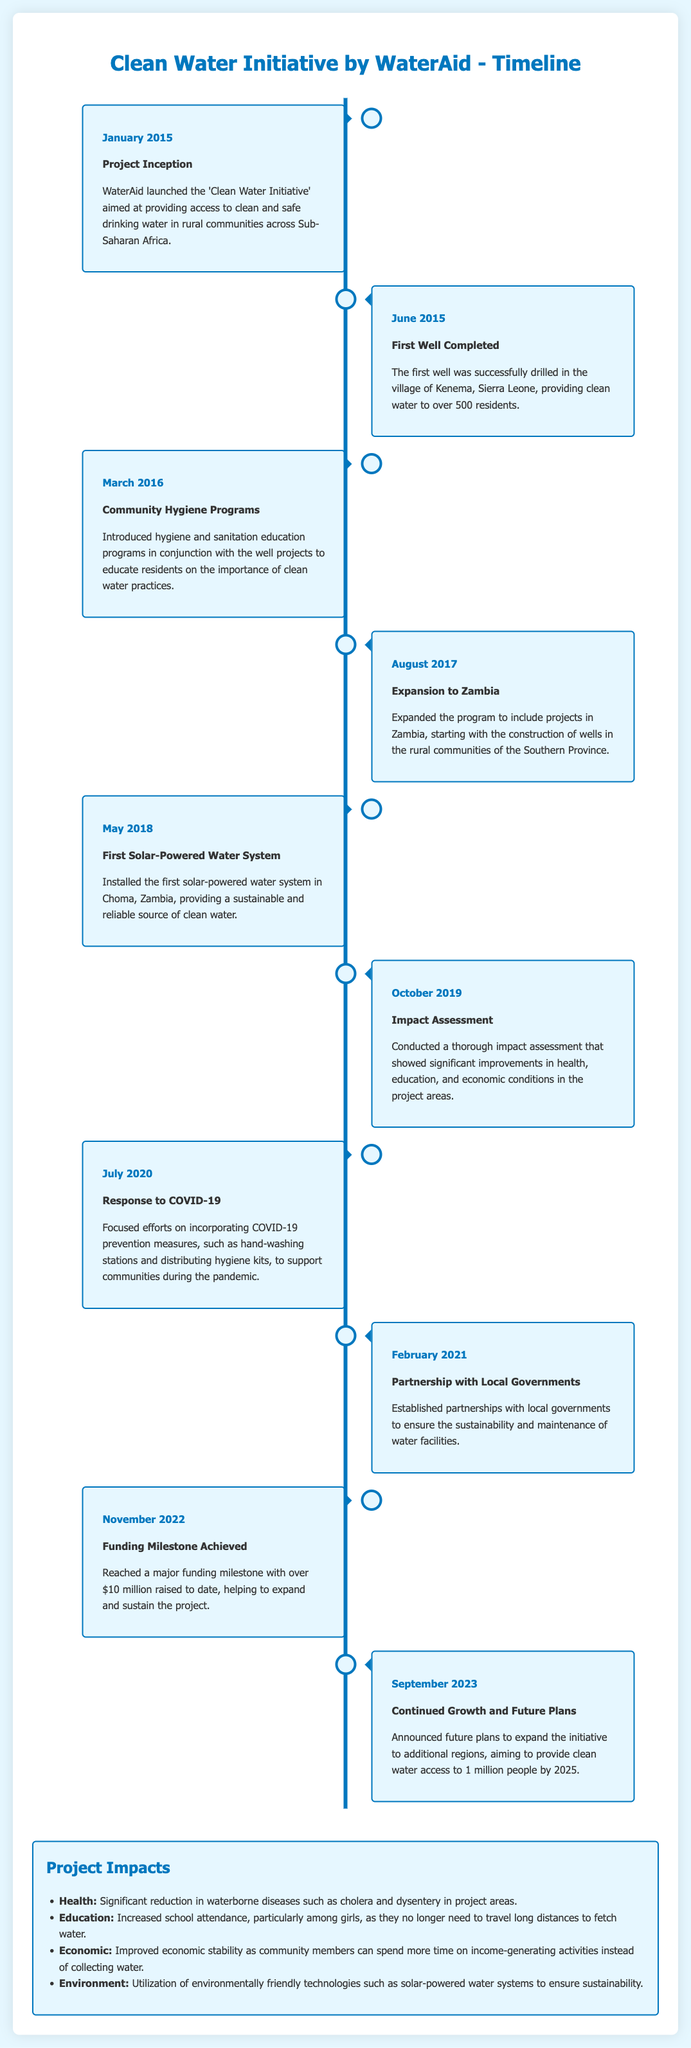What year did the Clean Water Initiative begin? The Clean Water Initiative was launched in January 2015.
Answer: January 2015 How many residents benefited from the first well in Kenema, Sierra Leone? The first well provided clean water to over 500 residents.
Answer: over 500 residents What significant technology was implemented in May 2018? The first solar-powered water system was installed in Choma, Zambia.
Answer: solar-powered water system Which area was added to the project in August 2017? The project expanded to include Zambia.
Answer: Zambia What was the funding milestone achieved in November 2022? Over $10 million was raised to date.
Answer: over $10 million What outcome was linked to increased school attendance? The initiative helped particularly girls who no longer need to travel long distances to fetch water.
Answer: increased school attendance for girls Why were partnerships established with local governments in February 2021? To ensure sustainability and maintenance of water facilities.
Answer: sustainability and maintenance What type of assessment was conducted in October 2019? A thorough impact assessment was conducted.
Answer: impact assessment What is the future goal for providing clean water access by 2025? The goal is to provide clean water access to 1 million people.
Answer: 1 million people 